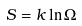Convert formula to latex. <formula><loc_0><loc_0><loc_500><loc_500>S = k \ln \Omega</formula> 